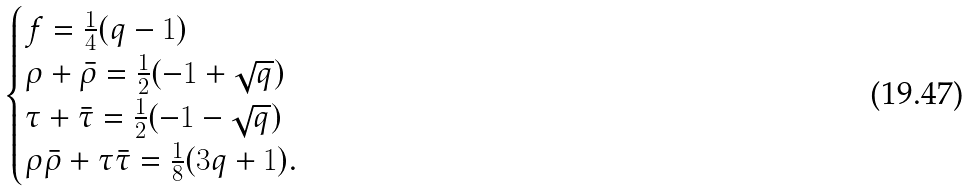<formula> <loc_0><loc_0><loc_500><loc_500>\begin{cases} f = \frac { 1 } { 4 } ( q - 1 ) \\ \rho + \bar { \rho } = \frac { 1 } { 2 } ( - 1 + \sqrt { q } ) \\ \tau + \bar { \tau } = \frac { 1 } { 2 } ( - 1 - \sqrt { q } ) \\ \rho \bar { \rho } + \tau \bar { \tau } = \frac { 1 } { 8 } ( 3 q + 1 ) . \end{cases}</formula> 